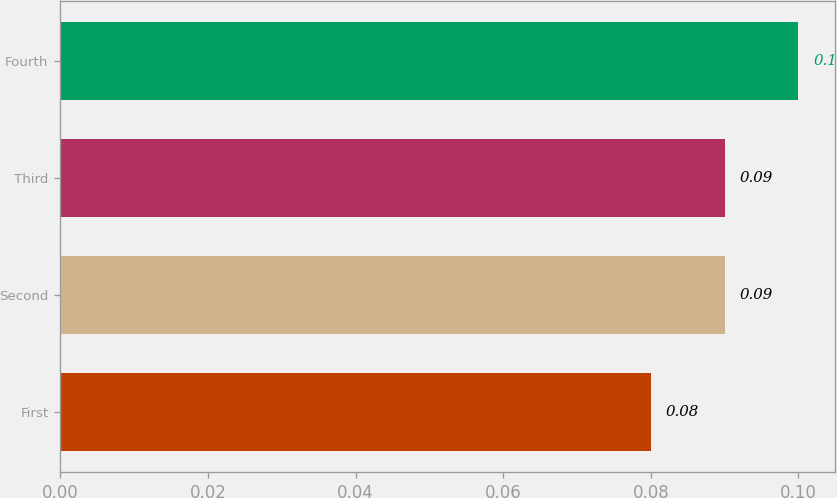<chart> <loc_0><loc_0><loc_500><loc_500><bar_chart><fcel>First<fcel>Second<fcel>Third<fcel>Fourth<nl><fcel>0.08<fcel>0.09<fcel>0.09<fcel>0.1<nl></chart> 